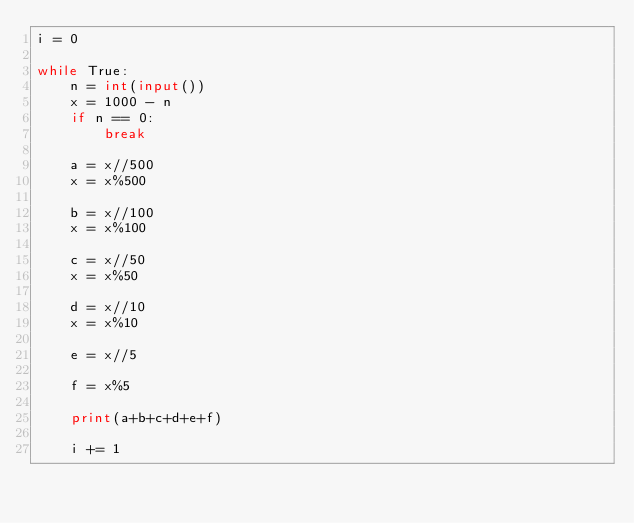<code> <loc_0><loc_0><loc_500><loc_500><_Python_>i = 0

while True:
    n = int(input())
    x = 1000 - n
    if n == 0:
        break
    
    a = x//500
    x = x%500
    
    b = x//100
    x = x%100
    
    c = x//50
    x = x%50
    
    d = x//10
    x = x%10
    
    e = x//5
    
    f = x%5
    
    print(a+b+c+d+e+f)
    
    i += 1
</code> 